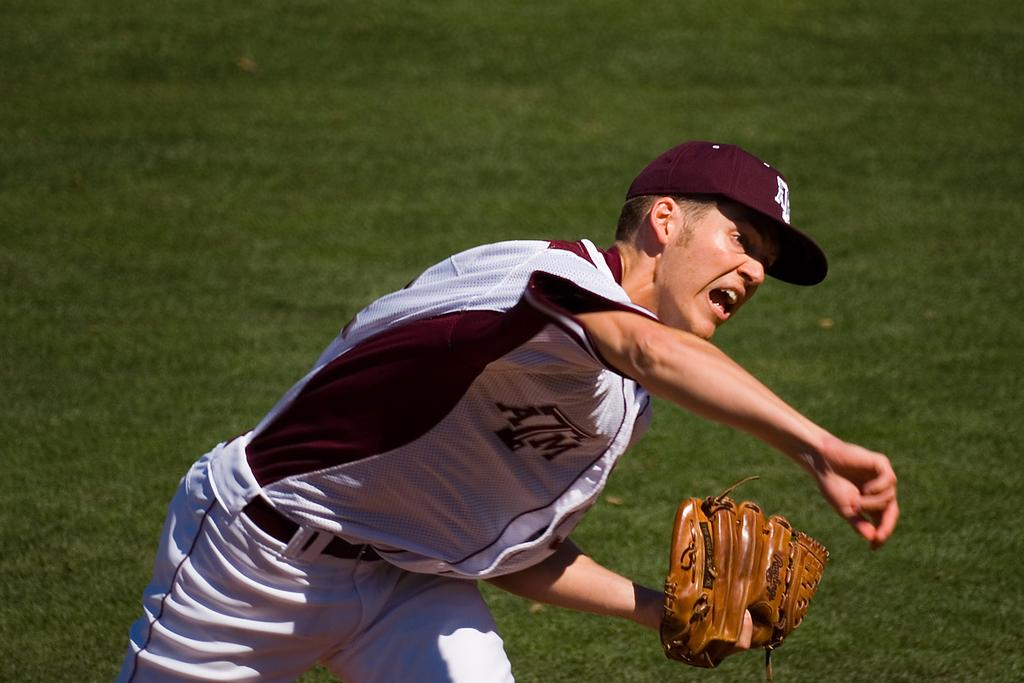Who is present in the image? There is a man in the image. What accessories is the man wearing? The man is wearing gloves and a cap. What type of surface is visible in the image? There is grass visible in the image. How many slaves are visible in the image? There are no slaves present in the image; it features a man wearing gloves and a cap. What type of kitty can be seen playing with the man's gloves in the image? There is no kitty present in the image; it only features a man wearing gloves and a cap. 